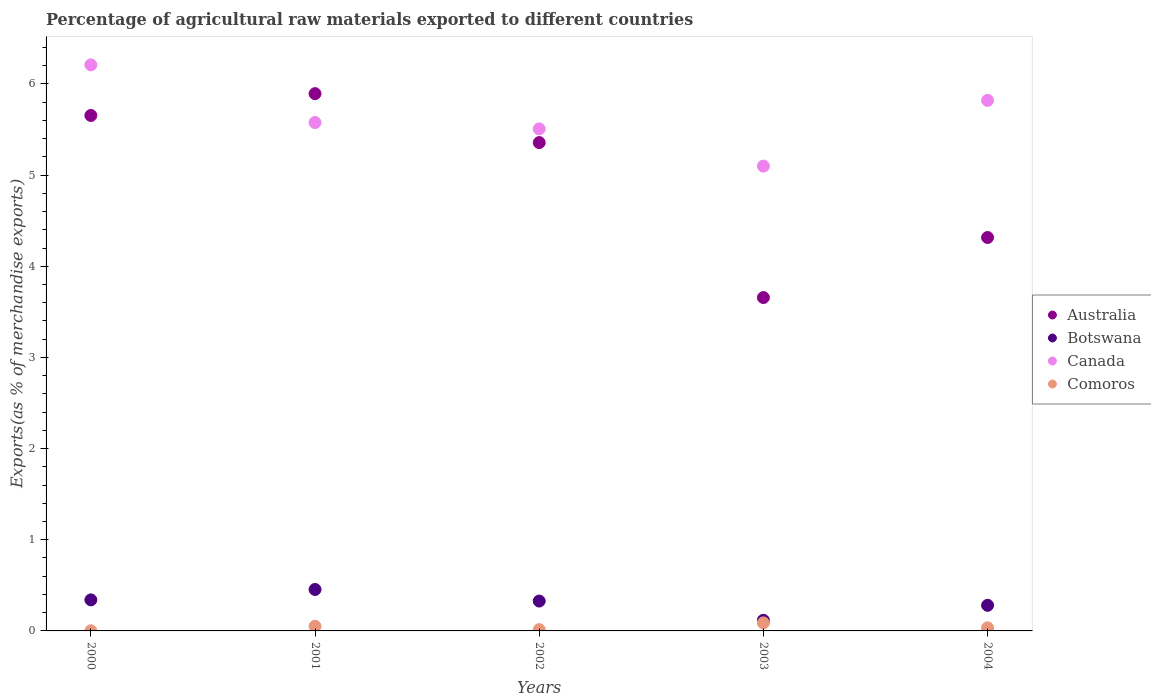What is the percentage of exports to different countries in Botswana in 2002?
Your answer should be compact. 0.33. Across all years, what is the maximum percentage of exports to different countries in Comoros?
Make the answer very short. 0.09. Across all years, what is the minimum percentage of exports to different countries in Botswana?
Your response must be concise. 0.12. In which year was the percentage of exports to different countries in Canada maximum?
Your response must be concise. 2000. In which year was the percentage of exports to different countries in Canada minimum?
Keep it short and to the point. 2003. What is the total percentage of exports to different countries in Comoros in the graph?
Ensure brevity in your answer.  0.19. What is the difference between the percentage of exports to different countries in Canada in 2000 and that in 2004?
Your response must be concise. 0.39. What is the difference between the percentage of exports to different countries in Botswana in 2004 and the percentage of exports to different countries in Comoros in 2002?
Make the answer very short. 0.27. What is the average percentage of exports to different countries in Australia per year?
Offer a terse response. 4.98. In the year 2003, what is the difference between the percentage of exports to different countries in Comoros and percentage of exports to different countries in Botswana?
Offer a very short reply. -0.03. In how many years, is the percentage of exports to different countries in Australia greater than 2.4 %?
Ensure brevity in your answer.  5. What is the ratio of the percentage of exports to different countries in Comoros in 2002 to that in 2004?
Make the answer very short. 0.41. What is the difference between the highest and the second highest percentage of exports to different countries in Comoros?
Provide a succinct answer. 0.04. What is the difference between the highest and the lowest percentage of exports to different countries in Canada?
Your answer should be very brief. 1.11. Is it the case that in every year, the sum of the percentage of exports to different countries in Comoros and percentage of exports to different countries in Canada  is greater than the percentage of exports to different countries in Botswana?
Your answer should be compact. Yes. Does the percentage of exports to different countries in Australia monotonically increase over the years?
Ensure brevity in your answer.  No. Is the percentage of exports to different countries in Botswana strictly greater than the percentage of exports to different countries in Canada over the years?
Keep it short and to the point. No. What is the difference between two consecutive major ticks on the Y-axis?
Ensure brevity in your answer.  1. How many legend labels are there?
Offer a very short reply. 4. What is the title of the graph?
Provide a short and direct response. Percentage of agricultural raw materials exported to different countries. What is the label or title of the Y-axis?
Offer a terse response. Exports(as % of merchandise exports). What is the Exports(as % of merchandise exports) of Australia in 2000?
Your response must be concise. 5.65. What is the Exports(as % of merchandise exports) in Botswana in 2000?
Offer a terse response. 0.34. What is the Exports(as % of merchandise exports) of Canada in 2000?
Ensure brevity in your answer.  6.21. What is the Exports(as % of merchandise exports) of Comoros in 2000?
Your response must be concise. 0. What is the Exports(as % of merchandise exports) in Australia in 2001?
Offer a very short reply. 5.89. What is the Exports(as % of merchandise exports) of Botswana in 2001?
Make the answer very short. 0.45. What is the Exports(as % of merchandise exports) of Canada in 2001?
Offer a terse response. 5.58. What is the Exports(as % of merchandise exports) of Comoros in 2001?
Your answer should be very brief. 0.05. What is the Exports(as % of merchandise exports) of Australia in 2002?
Make the answer very short. 5.36. What is the Exports(as % of merchandise exports) in Botswana in 2002?
Ensure brevity in your answer.  0.33. What is the Exports(as % of merchandise exports) in Canada in 2002?
Provide a short and direct response. 5.51. What is the Exports(as % of merchandise exports) in Comoros in 2002?
Offer a terse response. 0.01. What is the Exports(as % of merchandise exports) of Australia in 2003?
Your answer should be compact. 3.66. What is the Exports(as % of merchandise exports) in Botswana in 2003?
Offer a terse response. 0.12. What is the Exports(as % of merchandise exports) of Canada in 2003?
Your response must be concise. 5.1. What is the Exports(as % of merchandise exports) of Comoros in 2003?
Make the answer very short. 0.09. What is the Exports(as % of merchandise exports) of Australia in 2004?
Give a very brief answer. 4.32. What is the Exports(as % of merchandise exports) of Botswana in 2004?
Offer a terse response. 0.28. What is the Exports(as % of merchandise exports) in Canada in 2004?
Keep it short and to the point. 5.82. What is the Exports(as % of merchandise exports) in Comoros in 2004?
Keep it short and to the point. 0.03. Across all years, what is the maximum Exports(as % of merchandise exports) in Australia?
Make the answer very short. 5.89. Across all years, what is the maximum Exports(as % of merchandise exports) in Botswana?
Make the answer very short. 0.45. Across all years, what is the maximum Exports(as % of merchandise exports) of Canada?
Ensure brevity in your answer.  6.21. Across all years, what is the maximum Exports(as % of merchandise exports) in Comoros?
Keep it short and to the point. 0.09. Across all years, what is the minimum Exports(as % of merchandise exports) of Australia?
Provide a short and direct response. 3.66. Across all years, what is the minimum Exports(as % of merchandise exports) in Botswana?
Keep it short and to the point. 0.12. Across all years, what is the minimum Exports(as % of merchandise exports) of Canada?
Keep it short and to the point. 5.1. Across all years, what is the minimum Exports(as % of merchandise exports) in Comoros?
Provide a short and direct response. 0. What is the total Exports(as % of merchandise exports) of Australia in the graph?
Make the answer very short. 24.88. What is the total Exports(as % of merchandise exports) in Botswana in the graph?
Your response must be concise. 1.52. What is the total Exports(as % of merchandise exports) of Canada in the graph?
Your answer should be compact. 28.21. What is the total Exports(as % of merchandise exports) of Comoros in the graph?
Ensure brevity in your answer.  0.19. What is the difference between the Exports(as % of merchandise exports) of Australia in 2000 and that in 2001?
Keep it short and to the point. -0.24. What is the difference between the Exports(as % of merchandise exports) of Botswana in 2000 and that in 2001?
Provide a short and direct response. -0.11. What is the difference between the Exports(as % of merchandise exports) in Canada in 2000 and that in 2001?
Give a very brief answer. 0.63. What is the difference between the Exports(as % of merchandise exports) in Comoros in 2000 and that in 2001?
Your response must be concise. -0.05. What is the difference between the Exports(as % of merchandise exports) of Australia in 2000 and that in 2002?
Make the answer very short. 0.3. What is the difference between the Exports(as % of merchandise exports) of Botswana in 2000 and that in 2002?
Your answer should be very brief. 0.01. What is the difference between the Exports(as % of merchandise exports) in Canada in 2000 and that in 2002?
Make the answer very short. 0.7. What is the difference between the Exports(as % of merchandise exports) of Comoros in 2000 and that in 2002?
Give a very brief answer. -0.01. What is the difference between the Exports(as % of merchandise exports) in Australia in 2000 and that in 2003?
Offer a terse response. 2. What is the difference between the Exports(as % of merchandise exports) in Botswana in 2000 and that in 2003?
Keep it short and to the point. 0.22. What is the difference between the Exports(as % of merchandise exports) of Canada in 2000 and that in 2003?
Ensure brevity in your answer.  1.11. What is the difference between the Exports(as % of merchandise exports) in Comoros in 2000 and that in 2003?
Offer a terse response. -0.09. What is the difference between the Exports(as % of merchandise exports) of Australia in 2000 and that in 2004?
Keep it short and to the point. 1.34. What is the difference between the Exports(as % of merchandise exports) in Botswana in 2000 and that in 2004?
Offer a very short reply. 0.06. What is the difference between the Exports(as % of merchandise exports) in Canada in 2000 and that in 2004?
Make the answer very short. 0.39. What is the difference between the Exports(as % of merchandise exports) in Comoros in 2000 and that in 2004?
Ensure brevity in your answer.  -0.03. What is the difference between the Exports(as % of merchandise exports) of Australia in 2001 and that in 2002?
Your answer should be very brief. 0.54. What is the difference between the Exports(as % of merchandise exports) in Botswana in 2001 and that in 2002?
Keep it short and to the point. 0.13. What is the difference between the Exports(as % of merchandise exports) of Canada in 2001 and that in 2002?
Offer a very short reply. 0.07. What is the difference between the Exports(as % of merchandise exports) in Comoros in 2001 and that in 2002?
Your answer should be very brief. 0.04. What is the difference between the Exports(as % of merchandise exports) in Australia in 2001 and that in 2003?
Provide a succinct answer. 2.24. What is the difference between the Exports(as % of merchandise exports) in Botswana in 2001 and that in 2003?
Give a very brief answer. 0.34. What is the difference between the Exports(as % of merchandise exports) of Canada in 2001 and that in 2003?
Provide a succinct answer. 0.48. What is the difference between the Exports(as % of merchandise exports) of Comoros in 2001 and that in 2003?
Your response must be concise. -0.04. What is the difference between the Exports(as % of merchandise exports) of Australia in 2001 and that in 2004?
Ensure brevity in your answer.  1.58. What is the difference between the Exports(as % of merchandise exports) in Botswana in 2001 and that in 2004?
Your answer should be very brief. 0.17. What is the difference between the Exports(as % of merchandise exports) of Canada in 2001 and that in 2004?
Your answer should be very brief. -0.24. What is the difference between the Exports(as % of merchandise exports) in Comoros in 2001 and that in 2004?
Give a very brief answer. 0.02. What is the difference between the Exports(as % of merchandise exports) in Australia in 2002 and that in 2003?
Your response must be concise. 1.7. What is the difference between the Exports(as % of merchandise exports) in Botswana in 2002 and that in 2003?
Keep it short and to the point. 0.21. What is the difference between the Exports(as % of merchandise exports) of Canada in 2002 and that in 2003?
Make the answer very short. 0.41. What is the difference between the Exports(as % of merchandise exports) of Comoros in 2002 and that in 2003?
Your response must be concise. -0.07. What is the difference between the Exports(as % of merchandise exports) of Australia in 2002 and that in 2004?
Provide a short and direct response. 1.04. What is the difference between the Exports(as % of merchandise exports) of Botswana in 2002 and that in 2004?
Ensure brevity in your answer.  0.05. What is the difference between the Exports(as % of merchandise exports) in Canada in 2002 and that in 2004?
Give a very brief answer. -0.31. What is the difference between the Exports(as % of merchandise exports) in Comoros in 2002 and that in 2004?
Offer a terse response. -0.02. What is the difference between the Exports(as % of merchandise exports) in Australia in 2003 and that in 2004?
Give a very brief answer. -0.66. What is the difference between the Exports(as % of merchandise exports) of Botswana in 2003 and that in 2004?
Your answer should be compact. -0.16. What is the difference between the Exports(as % of merchandise exports) of Canada in 2003 and that in 2004?
Offer a very short reply. -0.72. What is the difference between the Exports(as % of merchandise exports) in Comoros in 2003 and that in 2004?
Make the answer very short. 0.05. What is the difference between the Exports(as % of merchandise exports) of Australia in 2000 and the Exports(as % of merchandise exports) of Botswana in 2001?
Offer a terse response. 5.2. What is the difference between the Exports(as % of merchandise exports) in Australia in 2000 and the Exports(as % of merchandise exports) in Canada in 2001?
Keep it short and to the point. 0.08. What is the difference between the Exports(as % of merchandise exports) in Australia in 2000 and the Exports(as % of merchandise exports) in Comoros in 2001?
Offer a very short reply. 5.6. What is the difference between the Exports(as % of merchandise exports) in Botswana in 2000 and the Exports(as % of merchandise exports) in Canada in 2001?
Provide a succinct answer. -5.24. What is the difference between the Exports(as % of merchandise exports) in Botswana in 2000 and the Exports(as % of merchandise exports) in Comoros in 2001?
Your response must be concise. 0.29. What is the difference between the Exports(as % of merchandise exports) of Canada in 2000 and the Exports(as % of merchandise exports) of Comoros in 2001?
Your answer should be compact. 6.16. What is the difference between the Exports(as % of merchandise exports) of Australia in 2000 and the Exports(as % of merchandise exports) of Botswana in 2002?
Make the answer very short. 5.33. What is the difference between the Exports(as % of merchandise exports) in Australia in 2000 and the Exports(as % of merchandise exports) in Canada in 2002?
Ensure brevity in your answer.  0.15. What is the difference between the Exports(as % of merchandise exports) of Australia in 2000 and the Exports(as % of merchandise exports) of Comoros in 2002?
Offer a very short reply. 5.64. What is the difference between the Exports(as % of merchandise exports) of Botswana in 2000 and the Exports(as % of merchandise exports) of Canada in 2002?
Offer a terse response. -5.17. What is the difference between the Exports(as % of merchandise exports) in Botswana in 2000 and the Exports(as % of merchandise exports) in Comoros in 2002?
Make the answer very short. 0.33. What is the difference between the Exports(as % of merchandise exports) in Canada in 2000 and the Exports(as % of merchandise exports) in Comoros in 2002?
Keep it short and to the point. 6.2. What is the difference between the Exports(as % of merchandise exports) of Australia in 2000 and the Exports(as % of merchandise exports) of Botswana in 2003?
Provide a succinct answer. 5.54. What is the difference between the Exports(as % of merchandise exports) of Australia in 2000 and the Exports(as % of merchandise exports) of Canada in 2003?
Keep it short and to the point. 0.56. What is the difference between the Exports(as % of merchandise exports) in Australia in 2000 and the Exports(as % of merchandise exports) in Comoros in 2003?
Offer a very short reply. 5.57. What is the difference between the Exports(as % of merchandise exports) of Botswana in 2000 and the Exports(as % of merchandise exports) of Canada in 2003?
Your answer should be very brief. -4.76. What is the difference between the Exports(as % of merchandise exports) of Botswana in 2000 and the Exports(as % of merchandise exports) of Comoros in 2003?
Provide a succinct answer. 0.25. What is the difference between the Exports(as % of merchandise exports) in Canada in 2000 and the Exports(as % of merchandise exports) in Comoros in 2003?
Offer a terse response. 6.12. What is the difference between the Exports(as % of merchandise exports) in Australia in 2000 and the Exports(as % of merchandise exports) in Botswana in 2004?
Make the answer very short. 5.37. What is the difference between the Exports(as % of merchandise exports) of Australia in 2000 and the Exports(as % of merchandise exports) of Canada in 2004?
Offer a terse response. -0.17. What is the difference between the Exports(as % of merchandise exports) in Australia in 2000 and the Exports(as % of merchandise exports) in Comoros in 2004?
Make the answer very short. 5.62. What is the difference between the Exports(as % of merchandise exports) in Botswana in 2000 and the Exports(as % of merchandise exports) in Canada in 2004?
Your answer should be very brief. -5.48. What is the difference between the Exports(as % of merchandise exports) in Botswana in 2000 and the Exports(as % of merchandise exports) in Comoros in 2004?
Your answer should be very brief. 0.31. What is the difference between the Exports(as % of merchandise exports) of Canada in 2000 and the Exports(as % of merchandise exports) of Comoros in 2004?
Give a very brief answer. 6.18. What is the difference between the Exports(as % of merchandise exports) in Australia in 2001 and the Exports(as % of merchandise exports) in Botswana in 2002?
Offer a very short reply. 5.57. What is the difference between the Exports(as % of merchandise exports) in Australia in 2001 and the Exports(as % of merchandise exports) in Canada in 2002?
Make the answer very short. 0.39. What is the difference between the Exports(as % of merchandise exports) in Australia in 2001 and the Exports(as % of merchandise exports) in Comoros in 2002?
Make the answer very short. 5.88. What is the difference between the Exports(as % of merchandise exports) of Botswana in 2001 and the Exports(as % of merchandise exports) of Canada in 2002?
Your answer should be very brief. -5.05. What is the difference between the Exports(as % of merchandise exports) in Botswana in 2001 and the Exports(as % of merchandise exports) in Comoros in 2002?
Offer a very short reply. 0.44. What is the difference between the Exports(as % of merchandise exports) of Canada in 2001 and the Exports(as % of merchandise exports) of Comoros in 2002?
Make the answer very short. 5.56. What is the difference between the Exports(as % of merchandise exports) of Australia in 2001 and the Exports(as % of merchandise exports) of Botswana in 2003?
Keep it short and to the point. 5.78. What is the difference between the Exports(as % of merchandise exports) of Australia in 2001 and the Exports(as % of merchandise exports) of Canada in 2003?
Your answer should be very brief. 0.79. What is the difference between the Exports(as % of merchandise exports) of Australia in 2001 and the Exports(as % of merchandise exports) of Comoros in 2003?
Your answer should be very brief. 5.81. What is the difference between the Exports(as % of merchandise exports) of Botswana in 2001 and the Exports(as % of merchandise exports) of Canada in 2003?
Provide a short and direct response. -4.64. What is the difference between the Exports(as % of merchandise exports) of Botswana in 2001 and the Exports(as % of merchandise exports) of Comoros in 2003?
Provide a succinct answer. 0.37. What is the difference between the Exports(as % of merchandise exports) of Canada in 2001 and the Exports(as % of merchandise exports) of Comoros in 2003?
Provide a succinct answer. 5.49. What is the difference between the Exports(as % of merchandise exports) in Australia in 2001 and the Exports(as % of merchandise exports) in Botswana in 2004?
Ensure brevity in your answer.  5.61. What is the difference between the Exports(as % of merchandise exports) of Australia in 2001 and the Exports(as % of merchandise exports) of Canada in 2004?
Keep it short and to the point. 0.07. What is the difference between the Exports(as % of merchandise exports) of Australia in 2001 and the Exports(as % of merchandise exports) of Comoros in 2004?
Give a very brief answer. 5.86. What is the difference between the Exports(as % of merchandise exports) of Botswana in 2001 and the Exports(as % of merchandise exports) of Canada in 2004?
Provide a succinct answer. -5.37. What is the difference between the Exports(as % of merchandise exports) in Botswana in 2001 and the Exports(as % of merchandise exports) in Comoros in 2004?
Provide a succinct answer. 0.42. What is the difference between the Exports(as % of merchandise exports) of Canada in 2001 and the Exports(as % of merchandise exports) of Comoros in 2004?
Give a very brief answer. 5.54. What is the difference between the Exports(as % of merchandise exports) of Australia in 2002 and the Exports(as % of merchandise exports) of Botswana in 2003?
Give a very brief answer. 5.24. What is the difference between the Exports(as % of merchandise exports) of Australia in 2002 and the Exports(as % of merchandise exports) of Canada in 2003?
Provide a short and direct response. 0.26. What is the difference between the Exports(as % of merchandise exports) of Australia in 2002 and the Exports(as % of merchandise exports) of Comoros in 2003?
Offer a terse response. 5.27. What is the difference between the Exports(as % of merchandise exports) of Botswana in 2002 and the Exports(as % of merchandise exports) of Canada in 2003?
Ensure brevity in your answer.  -4.77. What is the difference between the Exports(as % of merchandise exports) in Botswana in 2002 and the Exports(as % of merchandise exports) in Comoros in 2003?
Your answer should be very brief. 0.24. What is the difference between the Exports(as % of merchandise exports) in Canada in 2002 and the Exports(as % of merchandise exports) in Comoros in 2003?
Offer a very short reply. 5.42. What is the difference between the Exports(as % of merchandise exports) in Australia in 2002 and the Exports(as % of merchandise exports) in Botswana in 2004?
Provide a short and direct response. 5.08. What is the difference between the Exports(as % of merchandise exports) in Australia in 2002 and the Exports(as % of merchandise exports) in Canada in 2004?
Your answer should be compact. -0.46. What is the difference between the Exports(as % of merchandise exports) of Australia in 2002 and the Exports(as % of merchandise exports) of Comoros in 2004?
Give a very brief answer. 5.32. What is the difference between the Exports(as % of merchandise exports) of Botswana in 2002 and the Exports(as % of merchandise exports) of Canada in 2004?
Your answer should be very brief. -5.49. What is the difference between the Exports(as % of merchandise exports) of Botswana in 2002 and the Exports(as % of merchandise exports) of Comoros in 2004?
Offer a very short reply. 0.29. What is the difference between the Exports(as % of merchandise exports) of Canada in 2002 and the Exports(as % of merchandise exports) of Comoros in 2004?
Ensure brevity in your answer.  5.47. What is the difference between the Exports(as % of merchandise exports) in Australia in 2003 and the Exports(as % of merchandise exports) in Botswana in 2004?
Give a very brief answer. 3.38. What is the difference between the Exports(as % of merchandise exports) of Australia in 2003 and the Exports(as % of merchandise exports) of Canada in 2004?
Provide a short and direct response. -2.16. What is the difference between the Exports(as % of merchandise exports) in Australia in 2003 and the Exports(as % of merchandise exports) in Comoros in 2004?
Ensure brevity in your answer.  3.62. What is the difference between the Exports(as % of merchandise exports) of Botswana in 2003 and the Exports(as % of merchandise exports) of Canada in 2004?
Your response must be concise. -5.7. What is the difference between the Exports(as % of merchandise exports) of Botswana in 2003 and the Exports(as % of merchandise exports) of Comoros in 2004?
Your answer should be very brief. 0.08. What is the difference between the Exports(as % of merchandise exports) of Canada in 2003 and the Exports(as % of merchandise exports) of Comoros in 2004?
Give a very brief answer. 5.07. What is the average Exports(as % of merchandise exports) in Australia per year?
Make the answer very short. 4.98. What is the average Exports(as % of merchandise exports) in Botswana per year?
Your answer should be very brief. 0.3. What is the average Exports(as % of merchandise exports) in Canada per year?
Keep it short and to the point. 5.64. What is the average Exports(as % of merchandise exports) of Comoros per year?
Make the answer very short. 0.04. In the year 2000, what is the difference between the Exports(as % of merchandise exports) in Australia and Exports(as % of merchandise exports) in Botswana?
Give a very brief answer. 5.31. In the year 2000, what is the difference between the Exports(as % of merchandise exports) in Australia and Exports(as % of merchandise exports) in Canada?
Your response must be concise. -0.56. In the year 2000, what is the difference between the Exports(as % of merchandise exports) in Australia and Exports(as % of merchandise exports) in Comoros?
Offer a terse response. 5.65. In the year 2000, what is the difference between the Exports(as % of merchandise exports) in Botswana and Exports(as % of merchandise exports) in Canada?
Provide a short and direct response. -5.87. In the year 2000, what is the difference between the Exports(as % of merchandise exports) in Botswana and Exports(as % of merchandise exports) in Comoros?
Ensure brevity in your answer.  0.34. In the year 2000, what is the difference between the Exports(as % of merchandise exports) of Canada and Exports(as % of merchandise exports) of Comoros?
Keep it short and to the point. 6.21. In the year 2001, what is the difference between the Exports(as % of merchandise exports) in Australia and Exports(as % of merchandise exports) in Botswana?
Your answer should be very brief. 5.44. In the year 2001, what is the difference between the Exports(as % of merchandise exports) of Australia and Exports(as % of merchandise exports) of Canada?
Offer a terse response. 0.32. In the year 2001, what is the difference between the Exports(as % of merchandise exports) of Australia and Exports(as % of merchandise exports) of Comoros?
Give a very brief answer. 5.84. In the year 2001, what is the difference between the Exports(as % of merchandise exports) in Botswana and Exports(as % of merchandise exports) in Canada?
Your answer should be compact. -5.12. In the year 2001, what is the difference between the Exports(as % of merchandise exports) of Botswana and Exports(as % of merchandise exports) of Comoros?
Provide a short and direct response. 0.4. In the year 2001, what is the difference between the Exports(as % of merchandise exports) of Canada and Exports(as % of merchandise exports) of Comoros?
Provide a succinct answer. 5.53. In the year 2002, what is the difference between the Exports(as % of merchandise exports) of Australia and Exports(as % of merchandise exports) of Botswana?
Your response must be concise. 5.03. In the year 2002, what is the difference between the Exports(as % of merchandise exports) in Australia and Exports(as % of merchandise exports) in Comoros?
Make the answer very short. 5.34. In the year 2002, what is the difference between the Exports(as % of merchandise exports) in Botswana and Exports(as % of merchandise exports) in Canada?
Provide a succinct answer. -5.18. In the year 2002, what is the difference between the Exports(as % of merchandise exports) of Botswana and Exports(as % of merchandise exports) of Comoros?
Offer a very short reply. 0.31. In the year 2002, what is the difference between the Exports(as % of merchandise exports) of Canada and Exports(as % of merchandise exports) of Comoros?
Your answer should be compact. 5.49. In the year 2003, what is the difference between the Exports(as % of merchandise exports) of Australia and Exports(as % of merchandise exports) of Botswana?
Keep it short and to the point. 3.54. In the year 2003, what is the difference between the Exports(as % of merchandise exports) in Australia and Exports(as % of merchandise exports) in Canada?
Offer a terse response. -1.44. In the year 2003, what is the difference between the Exports(as % of merchandise exports) of Australia and Exports(as % of merchandise exports) of Comoros?
Offer a terse response. 3.57. In the year 2003, what is the difference between the Exports(as % of merchandise exports) of Botswana and Exports(as % of merchandise exports) of Canada?
Your answer should be very brief. -4.98. In the year 2003, what is the difference between the Exports(as % of merchandise exports) in Botswana and Exports(as % of merchandise exports) in Comoros?
Provide a short and direct response. 0.03. In the year 2003, what is the difference between the Exports(as % of merchandise exports) in Canada and Exports(as % of merchandise exports) in Comoros?
Provide a short and direct response. 5.01. In the year 2004, what is the difference between the Exports(as % of merchandise exports) of Australia and Exports(as % of merchandise exports) of Botswana?
Provide a short and direct response. 4.04. In the year 2004, what is the difference between the Exports(as % of merchandise exports) in Australia and Exports(as % of merchandise exports) in Canada?
Offer a terse response. -1.5. In the year 2004, what is the difference between the Exports(as % of merchandise exports) in Australia and Exports(as % of merchandise exports) in Comoros?
Keep it short and to the point. 4.28. In the year 2004, what is the difference between the Exports(as % of merchandise exports) of Botswana and Exports(as % of merchandise exports) of Canada?
Provide a succinct answer. -5.54. In the year 2004, what is the difference between the Exports(as % of merchandise exports) of Botswana and Exports(as % of merchandise exports) of Comoros?
Your answer should be compact. 0.25. In the year 2004, what is the difference between the Exports(as % of merchandise exports) in Canada and Exports(as % of merchandise exports) in Comoros?
Offer a terse response. 5.79. What is the ratio of the Exports(as % of merchandise exports) in Australia in 2000 to that in 2001?
Your response must be concise. 0.96. What is the ratio of the Exports(as % of merchandise exports) in Botswana in 2000 to that in 2001?
Offer a very short reply. 0.75. What is the ratio of the Exports(as % of merchandise exports) of Canada in 2000 to that in 2001?
Make the answer very short. 1.11. What is the ratio of the Exports(as % of merchandise exports) of Comoros in 2000 to that in 2001?
Ensure brevity in your answer.  0.03. What is the ratio of the Exports(as % of merchandise exports) in Australia in 2000 to that in 2002?
Ensure brevity in your answer.  1.06. What is the ratio of the Exports(as % of merchandise exports) of Botswana in 2000 to that in 2002?
Ensure brevity in your answer.  1.04. What is the ratio of the Exports(as % of merchandise exports) in Canada in 2000 to that in 2002?
Provide a succinct answer. 1.13. What is the ratio of the Exports(as % of merchandise exports) of Comoros in 2000 to that in 2002?
Provide a succinct answer. 0.11. What is the ratio of the Exports(as % of merchandise exports) of Australia in 2000 to that in 2003?
Your response must be concise. 1.55. What is the ratio of the Exports(as % of merchandise exports) of Botswana in 2000 to that in 2003?
Your answer should be very brief. 2.92. What is the ratio of the Exports(as % of merchandise exports) in Canada in 2000 to that in 2003?
Your answer should be very brief. 1.22. What is the ratio of the Exports(as % of merchandise exports) in Comoros in 2000 to that in 2003?
Make the answer very short. 0.02. What is the ratio of the Exports(as % of merchandise exports) of Australia in 2000 to that in 2004?
Provide a short and direct response. 1.31. What is the ratio of the Exports(as % of merchandise exports) of Botswana in 2000 to that in 2004?
Your answer should be very brief. 1.21. What is the ratio of the Exports(as % of merchandise exports) of Canada in 2000 to that in 2004?
Provide a succinct answer. 1.07. What is the ratio of the Exports(as % of merchandise exports) of Comoros in 2000 to that in 2004?
Offer a very short reply. 0.05. What is the ratio of the Exports(as % of merchandise exports) in Australia in 2001 to that in 2002?
Offer a very short reply. 1.1. What is the ratio of the Exports(as % of merchandise exports) in Botswana in 2001 to that in 2002?
Offer a very short reply. 1.39. What is the ratio of the Exports(as % of merchandise exports) in Canada in 2001 to that in 2002?
Offer a terse response. 1.01. What is the ratio of the Exports(as % of merchandise exports) of Comoros in 2001 to that in 2002?
Offer a very short reply. 3.66. What is the ratio of the Exports(as % of merchandise exports) in Australia in 2001 to that in 2003?
Keep it short and to the point. 1.61. What is the ratio of the Exports(as % of merchandise exports) of Botswana in 2001 to that in 2003?
Your answer should be very brief. 3.89. What is the ratio of the Exports(as % of merchandise exports) of Canada in 2001 to that in 2003?
Your response must be concise. 1.09. What is the ratio of the Exports(as % of merchandise exports) in Comoros in 2001 to that in 2003?
Offer a very short reply. 0.58. What is the ratio of the Exports(as % of merchandise exports) of Australia in 2001 to that in 2004?
Offer a very short reply. 1.37. What is the ratio of the Exports(as % of merchandise exports) of Botswana in 2001 to that in 2004?
Offer a terse response. 1.62. What is the ratio of the Exports(as % of merchandise exports) of Canada in 2001 to that in 2004?
Your response must be concise. 0.96. What is the ratio of the Exports(as % of merchandise exports) of Comoros in 2001 to that in 2004?
Ensure brevity in your answer.  1.51. What is the ratio of the Exports(as % of merchandise exports) in Australia in 2002 to that in 2003?
Offer a terse response. 1.46. What is the ratio of the Exports(as % of merchandise exports) in Botswana in 2002 to that in 2003?
Give a very brief answer. 2.81. What is the ratio of the Exports(as % of merchandise exports) of Comoros in 2002 to that in 2003?
Keep it short and to the point. 0.16. What is the ratio of the Exports(as % of merchandise exports) of Australia in 2002 to that in 2004?
Your answer should be very brief. 1.24. What is the ratio of the Exports(as % of merchandise exports) of Botswana in 2002 to that in 2004?
Provide a succinct answer. 1.17. What is the ratio of the Exports(as % of merchandise exports) in Canada in 2002 to that in 2004?
Your answer should be very brief. 0.95. What is the ratio of the Exports(as % of merchandise exports) of Comoros in 2002 to that in 2004?
Ensure brevity in your answer.  0.41. What is the ratio of the Exports(as % of merchandise exports) of Australia in 2003 to that in 2004?
Provide a short and direct response. 0.85. What is the ratio of the Exports(as % of merchandise exports) in Botswana in 2003 to that in 2004?
Offer a terse response. 0.42. What is the ratio of the Exports(as % of merchandise exports) in Canada in 2003 to that in 2004?
Offer a terse response. 0.88. What is the ratio of the Exports(as % of merchandise exports) in Comoros in 2003 to that in 2004?
Your answer should be very brief. 2.61. What is the difference between the highest and the second highest Exports(as % of merchandise exports) of Australia?
Give a very brief answer. 0.24. What is the difference between the highest and the second highest Exports(as % of merchandise exports) of Botswana?
Offer a very short reply. 0.11. What is the difference between the highest and the second highest Exports(as % of merchandise exports) of Canada?
Provide a short and direct response. 0.39. What is the difference between the highest and the second highest Exports(as % of merchandise exports) in Comoros?
Offer a very short reply. 0.04. What is the difference between the highest and the lowest Exports(as % of merchandise exports) in Australia?
Your answer should be very brief. 2.24. What is the difference between the highest and the lowest Exports(as % of merchandise exports) of Botswana?
Your answer should be compact. 0.34. What is the difference between the highest and the lowest Exports(as % of merchandise exports) in Canada?
Give a very brief answer. 1.11. What is the difference between the highest and the lowest Exports(as % of merchandise exports) of Comoros?
Your answer should be compact. 0.09. 